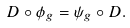<formula> <loc_0><loc_0><loc_500><loc_500>D \circ \phi _ { g } = \psi _ { g } \circ D .</formula> 